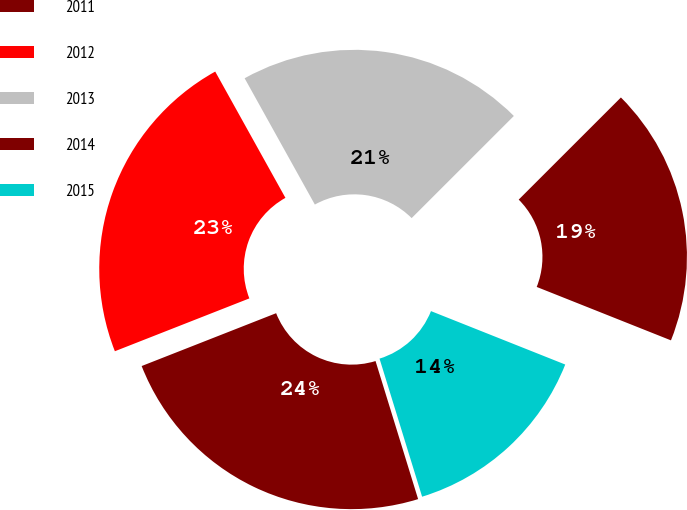Convert chart. <chart><loc_0><loc_0><loc_500><loc_500><pie_chart><fcel>2011<fcel>2012<fcel>2013<fcel>2014<fcel>2015<nl><fcel>23.8%<fcel>22.88%<fcel>20.58%<fcel>18.52%<fcel>14.21%<nl></chart> 